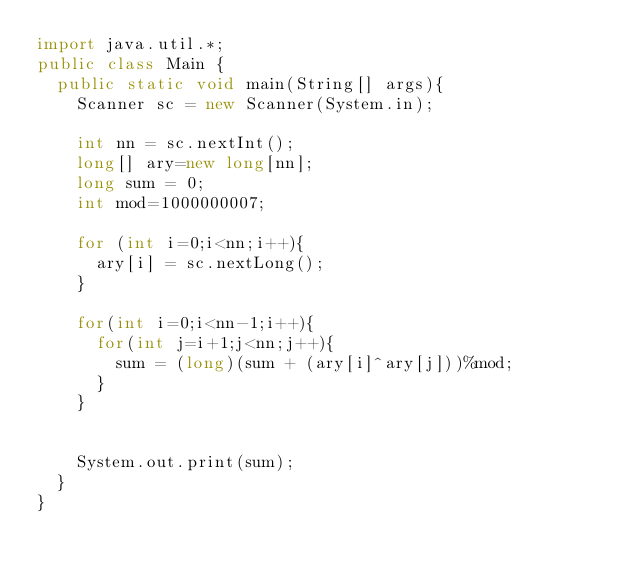Convert code to text. <code><loc_0><loc_0><loc_500><loc_500><_Java_>import java.util.*;
public class Main {
	public static void main(String[] args){
		Scanner sc = new Scanner(System.in);
		
		int nn = sc.nextInt();
		long[] ary=new long[nn];
		long sum = 0;
		int mod=1000000007;
		
		for (int i=0;i<nn;i++){
			ary[i] = sc.nextLong();
		}
		
		for(int i=0;i<nn-1;i++){
			for(int j=i+1;j<nn;j++){
				sum = (long)(sum + (ary[i]^ary[j]))%mod;
			}
		}
		
		
		System.out.print(sum);
	}
}</code> 